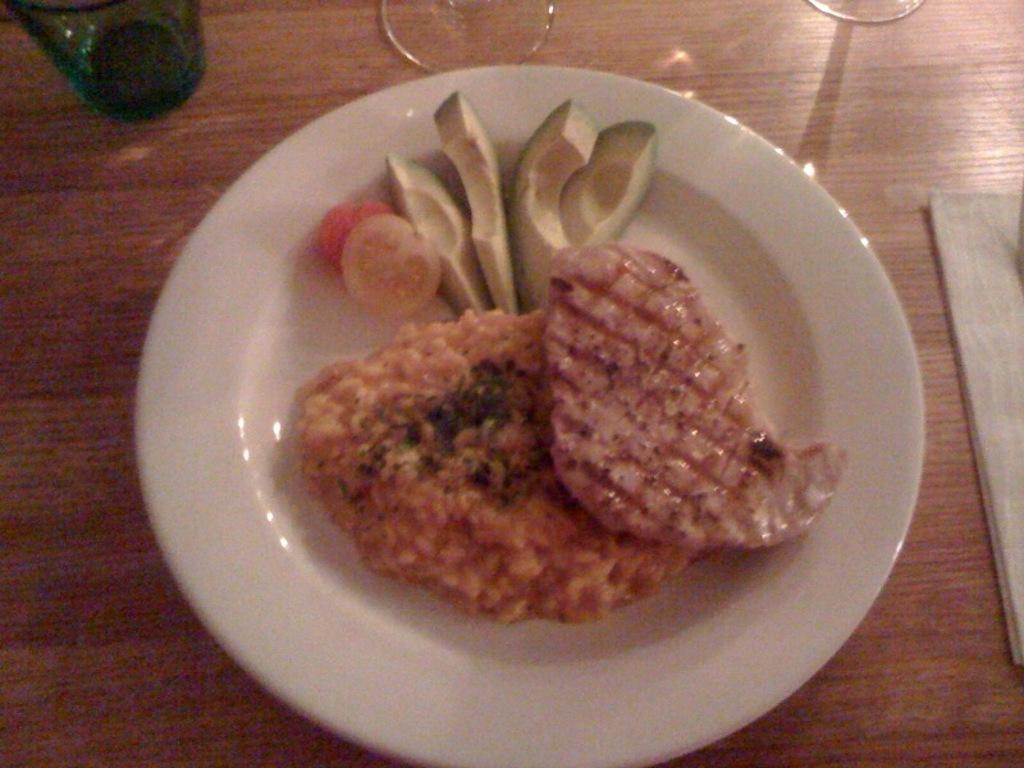What is on the white plate in the image? The plate contains mango pieces, tomato pieces, and meat. Are there any other food items on the plate? Yes, there are other food items on the plate. Where is the plate located in the image? The plate is placed on a table. What else can be seen on the table? There is a bottle, glasses, and a mat on the table. What language is being spoken by the lawyer in the image? There is no lawyer or spoken language present in the image. What is the view from the window in the image? There is no window or view in the image. 